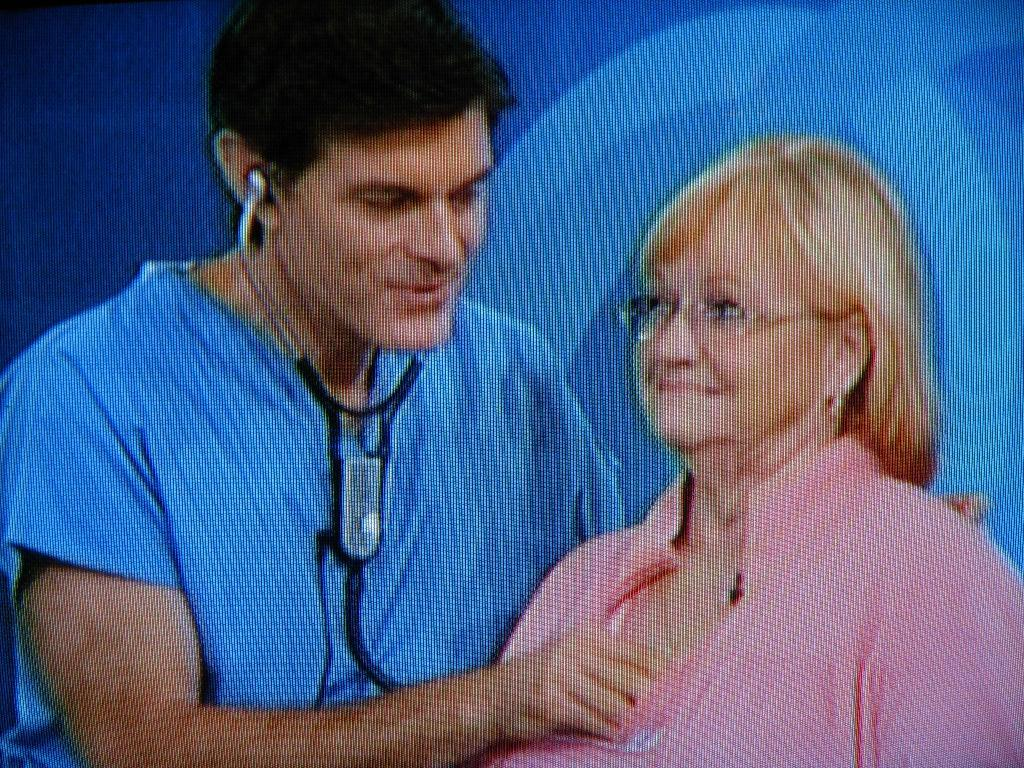What is the person holding in the image? The person is holding a stethoscope in the image. Can you describe the gender of the person in the image? There is a woman in the image. What color is the background of the image? The background of the image is blue. How many legs does the stethoscope have in the image? The stethoscope does not have legs; it is an inanimate object with two earpieces and a chest piece. 